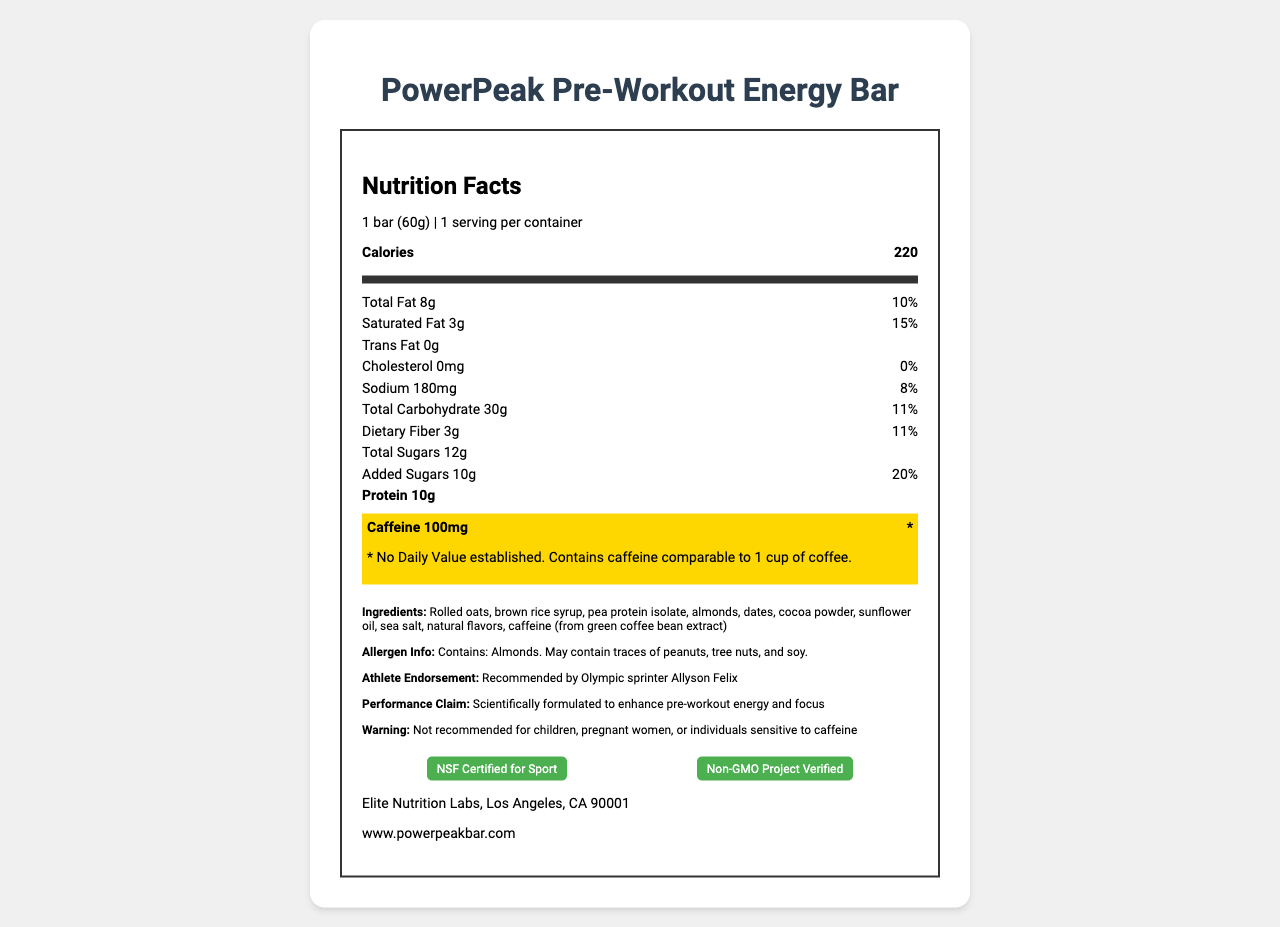What is the serving size of the PowerPeak Pre-Workout Energy Bar? The serving size is explicitly stated at the beginning of the Nutrition Facts Panel.
Answer: 1 bar (60g) How many grams of protein are in one serving of the PowerPeak Pre-Workout Energy Bar? The protein content per serving is listed as 10g in the Nutrition Facts section.
Answer: 10g What is the caffeine content in one bar of the PowerPeak Pre-Workout Energy Bar? The document highlights the caffeine content, stating it contains 100mg of caffeine per bar.
Answer: 100mg Which Olympic athlete endorses the PowerPeak Pre-Workout Energy Bar? The athlete endorsement section mentions Olympic sprinter Allyson Felix.
Answer: Allyson Felix What is the daily value percentage for total fat? The Nutrition Facts section states that the total fat content is 8g, which is 10% of the daily value.
Answer: 10% Which ingredient contributes to the added sugars in the energy bar? A. Pea Protein Isolate B. Dates C. Brown Rice Syrup Brown rice syrup is mentioned in the ingredients list and is a common source of added sugars.
Answer: C. Brown Rice Syrup What certifications does the PowerPeak Pre-Workout Energy Bar have? A. USDA Organic B. NSF Certified for Sport C. Gluten-Free D. Non-GMO Project Verified The certifications section lists NSF Certified for Sport and Non-GMO Project Verified.
Answer: B. NSF Certified for Sport, D. Non-GMO Project Verified Is the PowerPeak Pre-Workout Energy Bar safe for children? The warning section clearly states that the bar is not recommended for children, pregnant women, or individuals sensitive to caffeine.
Answer: No What is the main idea of this document? This explanation summarizes the various sections and the overall purpose of the document.
Answer: The document provides detailed nutrition facts and additional information about the PowerPeak Pre-Workout Energy Bar, including its ingredients, allergen information, athlete endorsement, performance claims, warnings, and certifications. Can we tell if the energy bar is suitable for someone with a soy allergy? The allergen information section mentions that the bar may contain traces of soy, suggesting caution, but it does not provide definitive information about its suitability for someone with a severe soy allergy.
Answer: Not enough information 